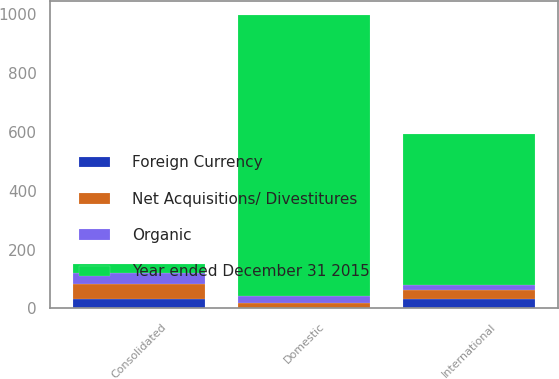<chart> <loc_0><loc_0><loc_500><loc_500><stacked_bar_chart><ecel><fcel>Consolidated<fcel>Domestic<fcel>International<nl><fcel>Year ended December 31 2015<fcel>30.9<fcel>954.7<fcel>513.7<nl><fcel>Foreign Currency<fcel>30.9<fcel>0<fcel>30.9<nl><fcel>Organic<fcel>37<fcel>21.9<fcel>15.1<nl><fcel>Net Acquisitions/ Divestitures<fcel>52.7<fcel>19.5<fcel>33.2<nl></chart> 